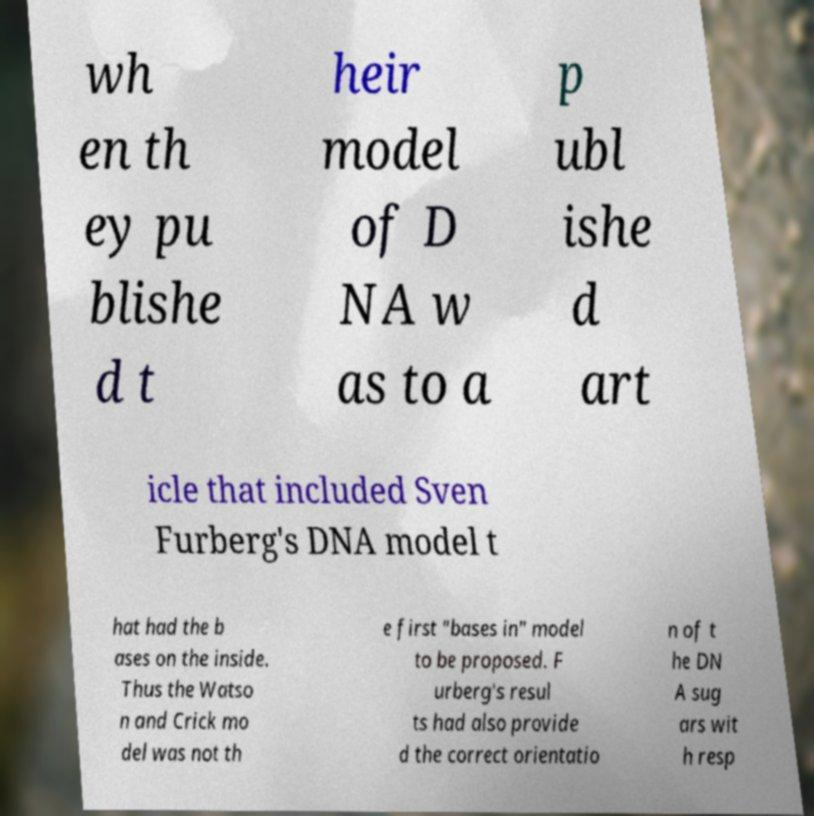Please identify and transcribe the text found in this image. wh en th ey pu blishe d t heir model of D NA w as to a p ubl ishe d art icle that included Sven Furberg's DNA model t hat had the b ases on the inside. Thus the Watso n and Crick mo del was not th e first "bases in" model to be proposed. F urberg's resul ts had also provide d the correct orientatio n of t he DN A sug ars wit h resp 